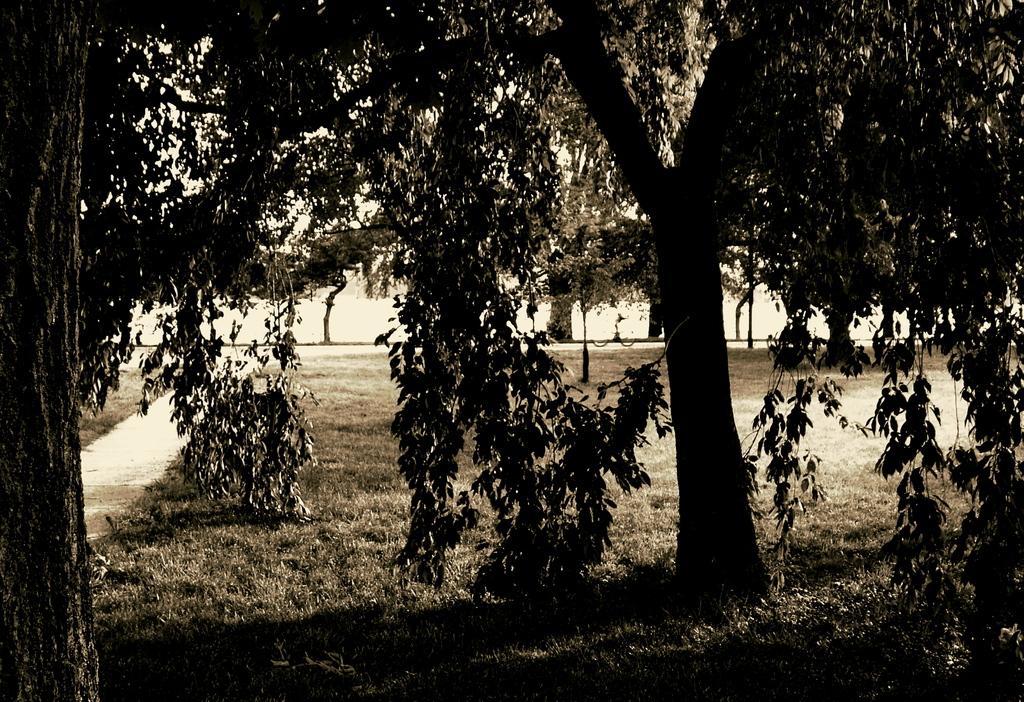Describe this image in one or two sentences. In this image we can see few trees and grass. 